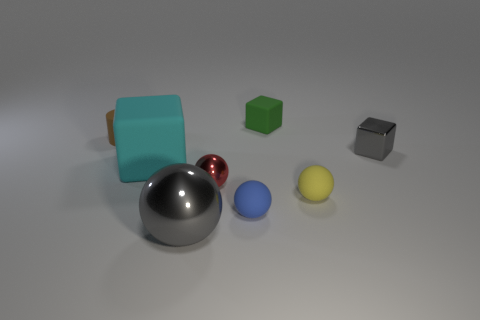What could be the purpose of this scene? Is it a realistic setting or a computer-generated simulation? This scene appears to be a computer-generated simulation designed to illustrate different shapes and materials. The clean and controlled environment suggests it's likely a model used for educational purposes or to demonstrate rendering techniques in computer graphics. 